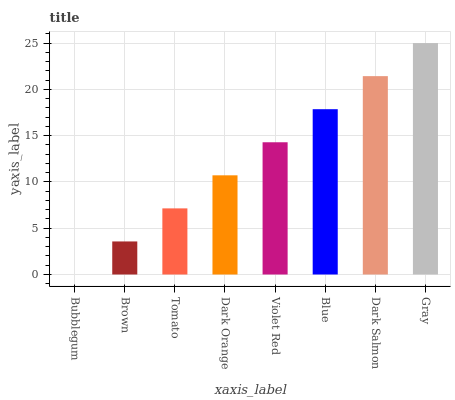Is Bubblegum the minimum?
Answer yes or no. Yes. Is Gray the maximum?
Answer yes or no. Yes. Is Brown the minimum?
Answer yes or no. No. Is Brown the maximum?
Answer yes or no. No. Is Brown greater than Bubblegum?
Answer yes or no. Yes. Is Bubblegum less than Brown?
Answer yes or no. Yes. Is Bubblegum greater than Brown?
Answer yes or no. No. Is Brown less than Bubblegum?
Answer yes or no. No. Is Violet Red the high median?
Answer yes or no. Yes. Is Dark Orange the low median?
Answer yes or no. Yes. Is Dark Orange the high median?
Answer yes or no. No. Is Blue the low median?
Answer yes or no. No. 